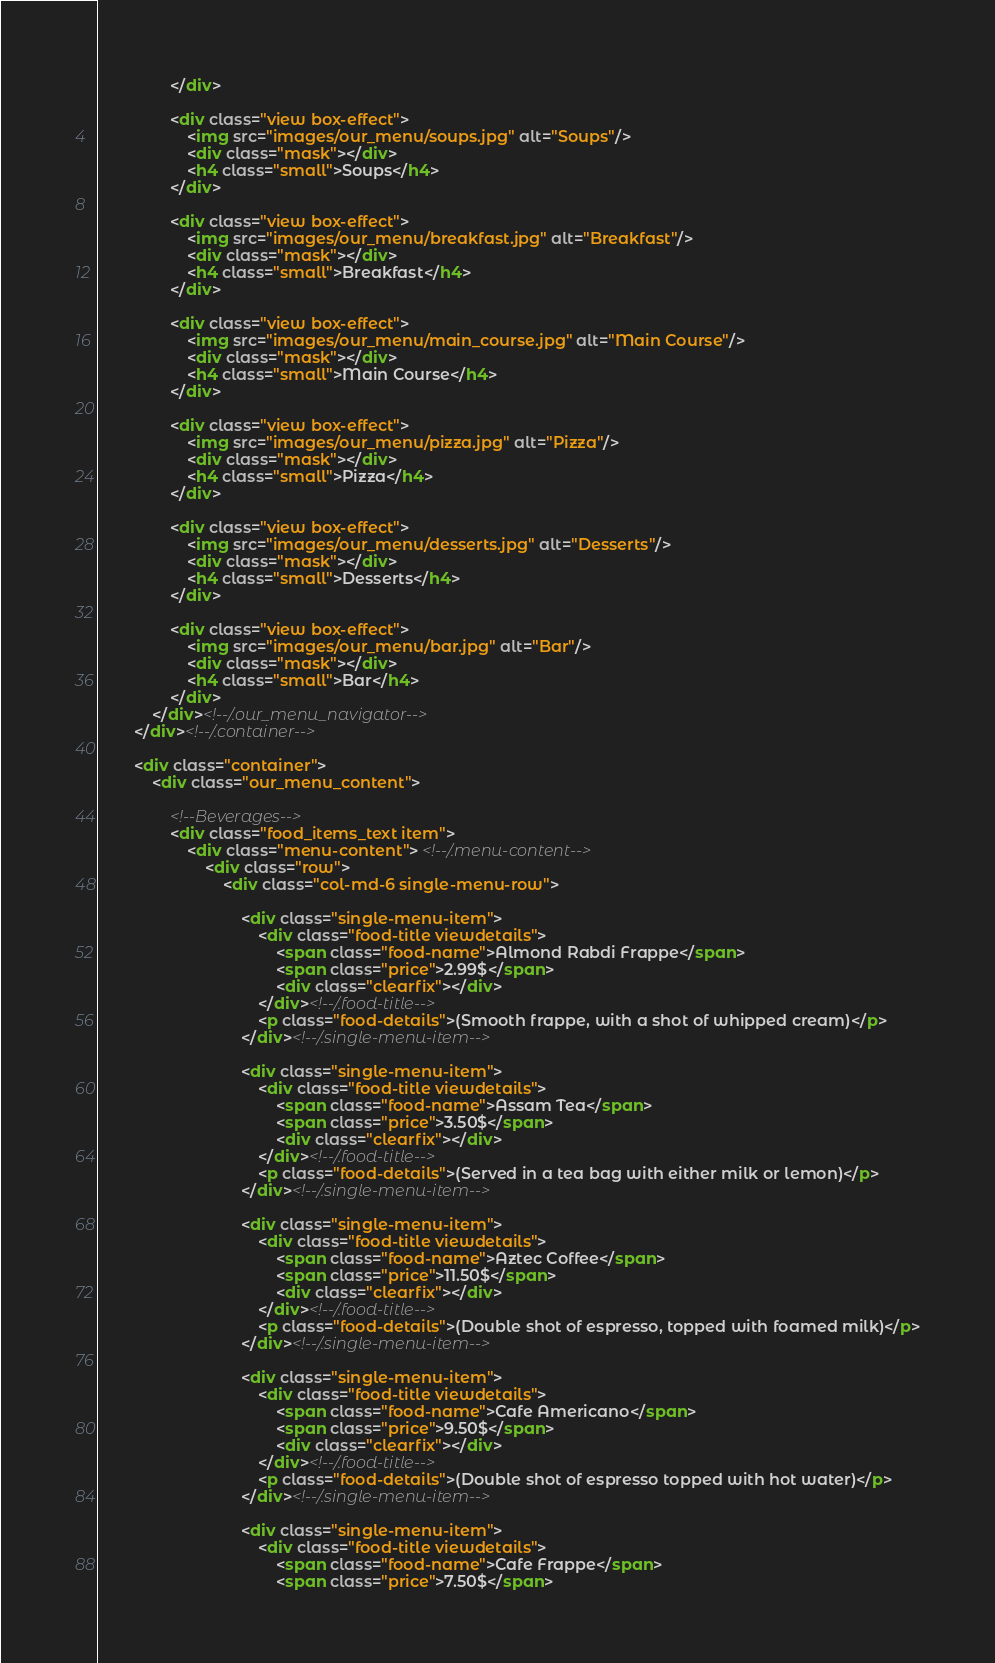<code> <loc_0><loc_0><loc_500><loc_500><_HTML_>                </div>     
                
                <div class="view box-effect">
                    <img src="images/our_menu/soups.jpg" alt="Soups"/>
                    <div class="mask"></div>
                    <h4 class="small">Soups</h4>
                </div>
                
                <div class="view box-effect">
                    <img src="images/our_menu/breakfast.jpg" alt="Breakfast"/>
                    <div class="mask"></div>
                    <h4 class="small">Breakfast</h4>
                </div>  
    
                <div class="view box-effect">
                    <img src="images/our_menu/main_course.jpg" alt="Main Course"/>
                    <div class="mask"></div>
                    <h4 class="small">Main Course</h4>
                </div>     
        
                <div class="view box-effect">
                    <img src="images/our_menu/pizza.jpg" alt="Pizza"/>
                    <div class="mask"></div>
                    <h4 class="small">Pizza</h4>
                </div>     
        
                <div class="view box-effect">
                    <img src="images/our_menu/desserts.jpg" alt="Desserts"/>
                    <div class="mask"></div>
                    <h4 class="small">Desserts</h4>
                </div>     
        
                <div class="view box-effect">
                    <img src="images/our_menu/bar.jpg" alt="Bar"/>
                    <div class="mask"></div>
                    <h4 class="small">Bar</h4>
                </div>
            </div><!--/.our_menu_navigator-->
        </div><!--/.container-->
                 
        <div class="container">
            <div class="our_menu_content">
            
                <!--Beverages-->
                <div class="food_items_text item">
                    <div class="menu-content"> <!--/.menu-content-->
                        <div class="row">
                            <div class="col-md-6 single-menu-row">
                            
                                <div class="single-menu-item">
                                    <div class="food-title viewdetails">
                                        <span class="food-name">Almond Rabdi Frappe</span>
                                        <span class="price">2.99$</span>
                                        <div class="clearfix"></div>
                                    </div><!--/.food-title-->
                                    <p class="food-details">(Smooth frappe, with a shot of whipped cream)</p>
                                </div><!--/.single-menu-item-->
                                    
                                <div class="single-menu-item">
                                    <div class="food-title viewdetails">
                                        <span class="food-name">Assam Tea</span>
                                        <span class="price">3.50$</span>
                                        <div class="clearfix"></div>
                                    </div><!--/.food-title-->
                                    <p class="food-details">(Served in a tea bag with either milk or lemon)</p>
                                </div><!--/.single-menu-item-->
                                    
                                <div class="single-menu-item">
                                    <div class="food-title viewdetails">
                                        <span class="food-name">Aztec Coffee</span>
                                        <span class="price">11.50$</span>
                                        <div class="clearfix"></div>
                                    </div><!--/.food-title-->
                                    <p class="food-details">(Double shot of espresso, topped with foamed milk)</p>
                                </div><!--/.single-menu-item-->
                                    
                                <div class="single-menu-item">
                                    <div class="food-title viewdetails">
                                        <span class="food-name">Cafe Americano</span>
                                        <span class="price">9.50$</span>
                                        <div class="clearfix"></div>
                                    </div><!--/.food-title-->
                                    <p class="food-details">(Double shot of espresso topped with hot water)</p>
                                </div><!--/.single-menu-item-->
            
                                <div class="single-menu-item">
                                    <div class="food-title viewdetails">
                                        <span class="food-name">Cafe Frappe</span>
                                        <span class="price">7.50$</span></code> 